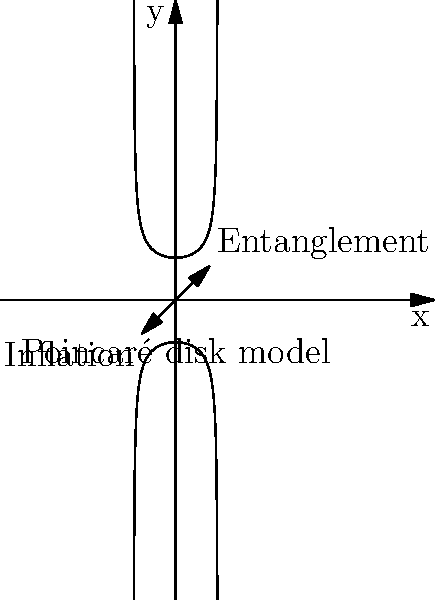In the context of quantum entanglement and cosmic inflation, how does the hyperbolic geometry represented in this Poincaré disk model relate to these phenomena? Explain the significance of the arrows labeled "Entanglement" and "Inflation" in terms of Non-Euclidean geometry and quantum mechanics. To understand the relationship between hyperbolic geometry, quantum entanglement, and cosmic inflation, we need to follow these steps:

1. Hyperbolic geometry: The Poincaré disk model shown in the image is a representation of hyperbolic geometry. In this model, the entire hyperbolic plane is mapped onto the interior of a circle.

2. Quantum entanglement: In quantum mechanics, entanglement describes a phenomenon where two or more particles are correlated in such a way that the quantum state of each particle cannot be described independently.

3. Cosmic inflation: This is a theory in physical cosmology that proposes an exponential expansion of space in the early universe.

4. Relationship to hyperbolic geometry:
   a) Entanglement arrow: Points towards the edge of the Poincaré disk. In hyperbolic geometry, as you move towards the edge, distances appear to stretch. This can be analogous to how entangled particles maintain correlations over large distances.
   b) Inflation arrow: Points in the opposite direction. This represents the rapid expansion of space during cosmic inflation, which can be modeled using hyperbolic geometry.

5. Non-Euclidean geometry connection: Both quantum entanglement and cosmic inflation involve concepts that defy our classical, Euclidean intuition. Hyperbolic geometry provides a mathematical framework to represent these non-intuitive phenomena.

6. Quantum mechanics interpretation: The curvature of space in hyperbolic geometry can be used to represent the complex probability spaces in quantum mechanics, particularly in describing entangled states.

7. Holographic principle: Some theories suggest that quantum information can be encoded on a lower-dimensional boundary of a region, similar to how the hyperbolic plane is represented on the 2D disk in the Poincaré model.

In essence, the hyperbolic geometry model serves as a bridge between the microscopic world of quantum mechanics and the macroscopic realm of cosmology, providing a geometric interpretation of phenomena that are difficult to visualize in standard Euclidean space.
Answer: Hyperbolic geometry models quantum entanglement's non-local correlations and cosmic inflation's space expansion, bridging quantum and cosmological scales. 